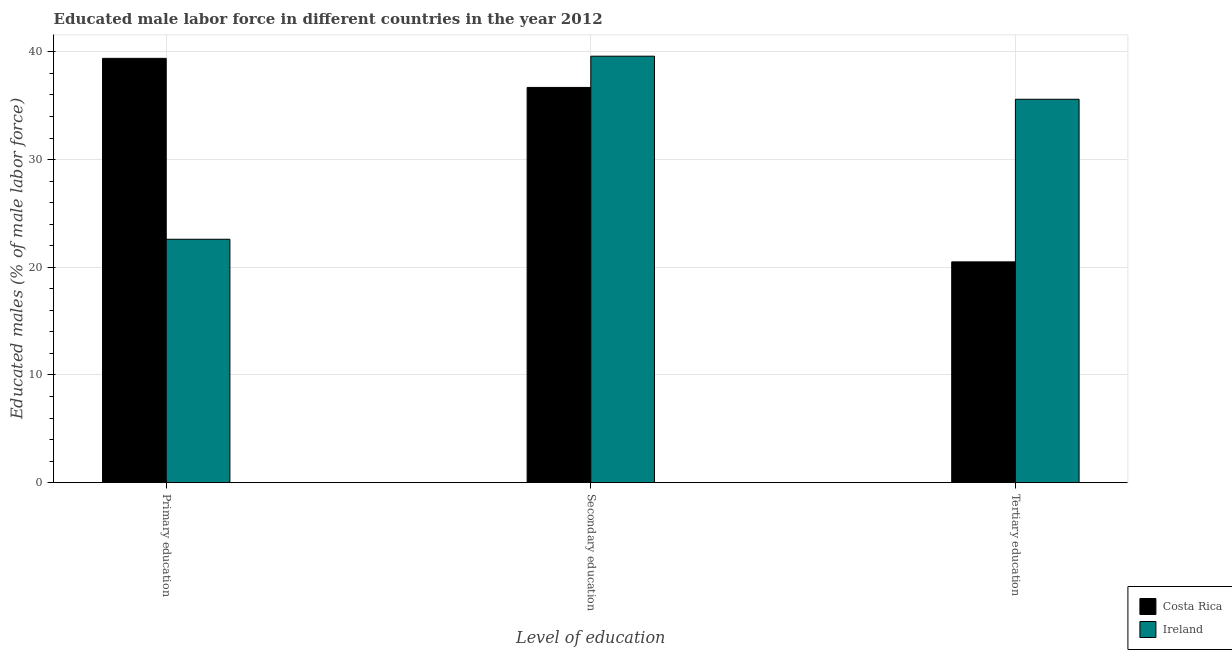How many different coloured bars are there?
Give a very brief answer. 2. Are the number of bars per tick equal to the number of legend labels?
Ensure brevity in your answer.  Yes. Are the number of bars on each tick of the X-axis equal?
Make the answer very short. Yes. What is the percentage of male labor force who received primary education in Ireland?
Offer a very short reply. 22.6. Across all countries, what is the maximum percentage of male labor force who received tertiary education?
Offer a very short reply. 35.6. Across all countries, what is the minimum percentage of male labor force who received secondary education?
Provide a succinct answer. 36.7. In which country was the percentage of male labor force who received tertiary education minimum?
Give a very brief answer. Costa Rica. What is the total percentage of male labor force who received primary education in the graph?
Provide a succinct answer. 62. What is the difference between the percentage of male labor force who received tertiary education in Costa Rica and that in Ireland?
Offer a very short reply. -15.1. What is the difference between the percentage of male labor force who received tertiary education in Costa Rica and the percentage of male labor force who received secondary education in Ireland?
Offer a very short reply. -19.1. What is the average percentage of male labor force who received tertiary education per country?
Offer a very short reply. 28.05. What is the difference between the percentage of male labor force who received tertiary education and percentage of male labor force who received primary education in Costa Rica?
Offer a very short reply. -18.9. What is the ratio of the percentage of male labor force who received secondary education in Costa Rica to that in Ireland?
Your answer should be very brief. 0.93. What is the difference between the highest and the second highest percentage of male labor force who received tertiary education?
Your answer should be very brief. 15.1. What is the difference between the highest and the lowest percentage of male labor force who received secondary education?
Offer a very short reply. 2.9. Is the sum of the percentage of male labor force who received primary education in Ireland and Costa Rica greater than the maximum percentage of male labor force who received secondary education across all countries?
Ensure brevity in your answer.  Yes. How many countries are there in the graph?
Ensure brevity in your answer.  2. What is the difference between two consecutive major ticks on the Y-axis?
Make the answer very short. 10. Does the graph contain grids?
Offer a very short reply. Yes. How many legend labels are there?
Your answer should be very brief. 2. How are the legend labels stacked?
Your response must be concise. Vertical. What is the title of the graph?
Give a very brief answer. Educated male labor force in different countries in the year 2012. What is the label or title of the X-axis?
Keep it short and to the point. Level of education. What is the label or title of the Y-axis?
Your answer should be compact. Educated males (% of male labor force). What is the Educated males (% of male labor force) in Costa Rica in Primary education?
Make the answer very short. 39.4. What is the Educated males (% of male labor force) of Ireland in Primary education?
Provide a short and direct response. 22.6. What is the Educated males (% of male labor force) of Costa Rica in Secondary education?
Your answer should be very brief. 36.7. What is the Educated males (% of male labor force) of Ireland in Secondary education?
Your answer should be compact. 39.6. What is the Educated males (% of male labor force) in Costa Rica in Tertiary education?
Your answer should be very brief. 20.5. What is the Educated males (% of male labor force) in Ireland in Tertiary education?
Your response must be concise. 35.6. Across all Level of education, what is the maximum Educated males (% of male labor force) in Costa Rica?
Offer a very short reply. 39.4. Across all Level of education, what is the maximum Educated males (% of male labor force) of Ireland?
Offer a very short reply. 39.6. Across all Level of education, what is the minimum Educated males (% of male labor force) of Costa Rica?
Your response must be concise. 20.5. Across all Level of education, what is the minimum Educated males (% of male labor force) of Ireland?
Offer a very short reply. 22.6. What is the total Educated males (% of male labor force) in Costa Rica in the graph?
Ensure brevity in your answer.  96.6. What is the total Educated males (% of male labor force) of Ireland in the graph?
Offer a terse response. 97.8. What is the difference between the Educated males (% of male labor force) of Ireland in Primary education and that in Secondary education?
Your answer should be very brief. -17. What is the difference between the Educated males (% of male labor force) of Ireland in Primary education and that in Tertiary education?
Ensure brevity in your answer.  -13. What is the difference between the Educated males (% of male labor force) in Costa Rica in Secondary education and that in Tertiary education?
Make the answer very short. 16.2. What is the difference between the Educated males (% of male labor force) of Costa Rica in Primary education and the Educated males (% of male labor force) of Ireland in Secondary education?
Provide a succinct answer. -0.2. What is the difference between the Educated males (% of male labor force) of Costa Rica in Primary education and the Educated males (% of male labor force) of Ireland in Tertiary education?
Provide a succinct answer. 3.8. What is the difference between the Educated males (% of male labor force) in Costa Rica in Secondary education and the Educated males (% of male labor force) in Ireland in Tertiary education?
Your response must be concise. 1.1. What is the average Educated males (% of male labor force) in Costa Rica per Level of education?
Offer a very short reply. 32.2. What is the average Educated males (% of male labor force) of Ireland per Level of education?
Provide a succinct answer. 32.6. What is the difference between the Educated males (% of male labor force) in Costa Rica and Educated males (% of male labor force) in Ireland in Tertiary education?
Your answer should be compact. -15.1. What is the ratio of the Educated males (% of male labor force) in Costa Rica in Primary education to that in Secondary education?
Keep it short and to the point. 1.07. What is the ratio of the Educated males (% of male labor force) in Ireland in Primary education to that in Secondary education?
Provide a short and direct response. 0.57. What is the ratio of the Educated males (% of male labor force) of Costa Rica in Primary education to that in Tertiary education?
Make the answer very short. 1.92. What is the ratio of the Educated males (% of male labor force) of Ireland in Primary education to that in Tertiary education?
Your answer should be compact. 0.63. What is the ratio of the Educated males (% of male labor force) in Costa Rica in Secondary education to that in Tertiary education?
Provide a short and direct response. 1.79. What is the ratio of the Educated males (% of male labor force) in Ireland in Secondary education to that in Tertiary education?
Your answer should be compact. 1.11. What is the difference between the highest and the second highest Educated males (% of male labor force) of Costa Rica?
Provide a succinct answer. 2.7. What is the difference between the highest and the lowest Educated males (% of male labor force) in Costa Rica?
Offer a very short reply. 18.9. 